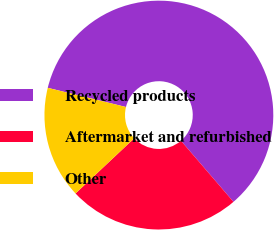Convert chart. <chart><loc_0><loc_0><loc_500><loc_500><pie_chart><fcel>Recycled products<fcel>Aftermarket and refurbished<fcel>Other<nl><fcel>59.87%<fcel>24.29%<fcel>15.84%<nl></chart> 